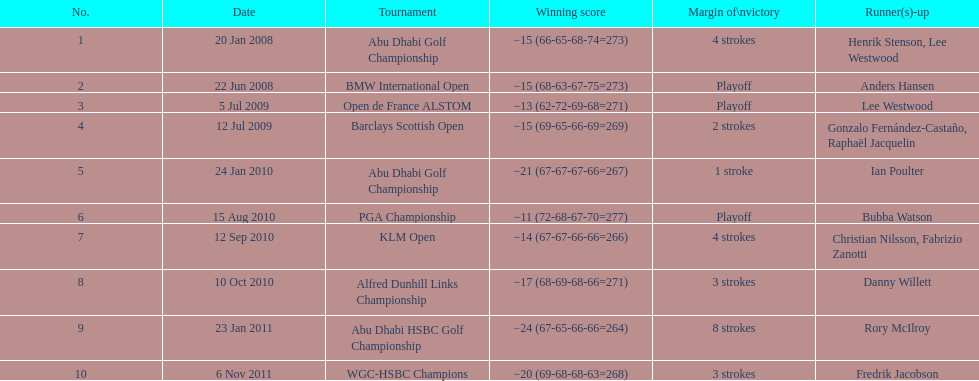How long separated the playoff victory at bmw international open and the 4 stroke victory at the klm open? 2 years. 